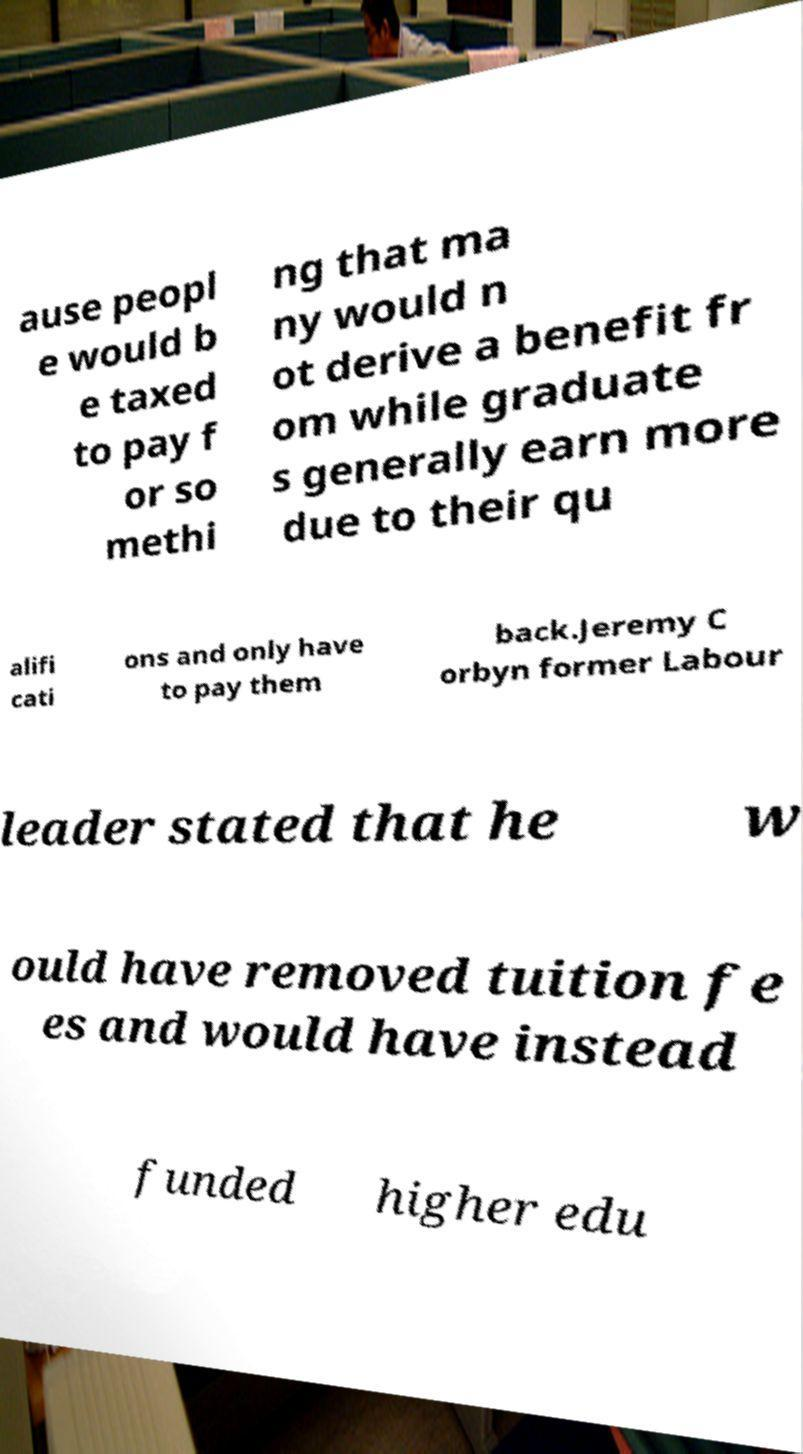What messages or text are displayed in this image? I need them in a readable, typed format. ause peopl e would b e taxed to pay f or so methi ng that ma ny would n ot derive a benefit fr om while graduate s generally earn more due to their qu alifi cati ons and only have to pay them back.Jeremy C orbyn former Labour leader stated that he w ould have removed tuition fe es and would have instead funded higher edu 